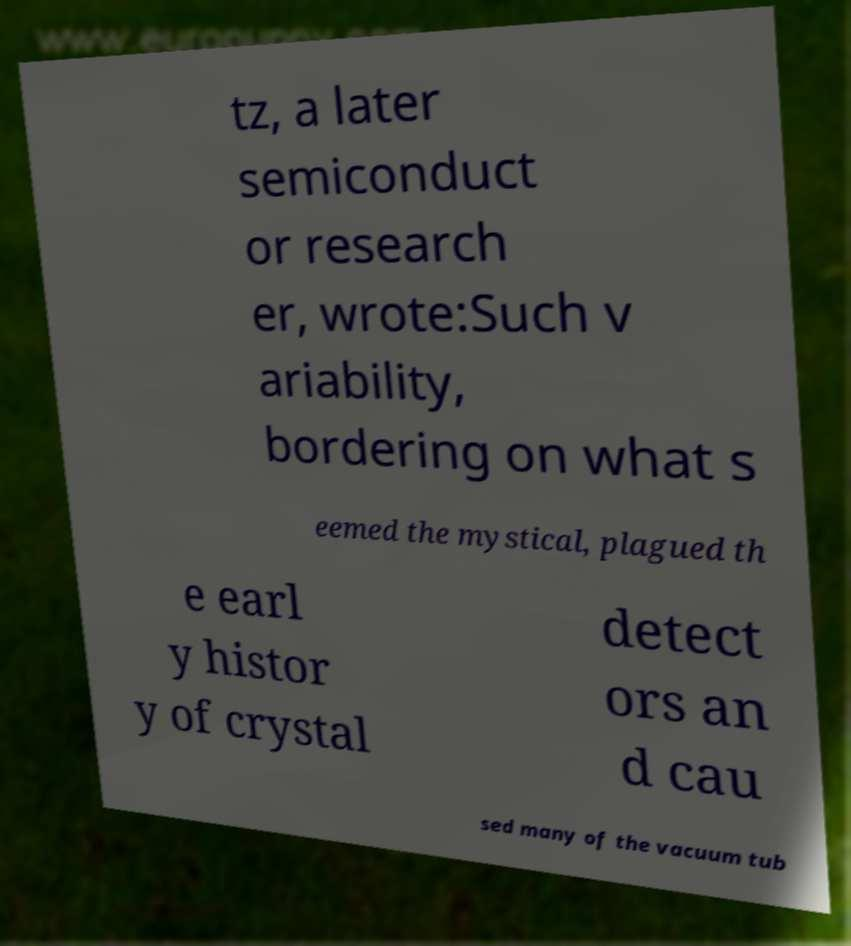Can you read and provide the text displayed in the image?This photo seems to have some interesting text. Can you extract and type it out for me? tz, a later semiconduct or research er, wrote:Such v ariability, bordering on what s eemed the mystical, plagued th e earl y histor y of crystal detect ors an d cau sed many of the vacuum tub 